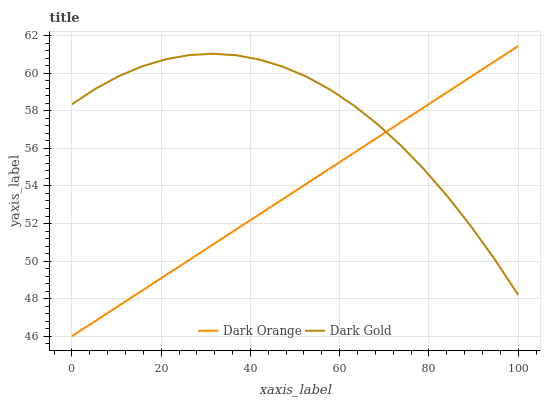Does Dark Orange have the minimum area under the curve?
Answer yes or no. Yes. Does Dark Gold have the maximum area under the curve?
Answer yes or no. Yes. Does Dark Gold have the minimum area under the curve?
Answer yes or no. No. Is Dark Orange the smoothest?
Answer yes or no. Yes. Is Dark Gold the roughest?
Answer yes or no. Yes. Is Dark Gold the smoothest?
Answer yes or no. No. Does Dark Orange have the lowest value?
Answer yes or no. Yes. Does Dark Gold have the lowest value?
Answer yes or no. No. Does Dark Orange have the highest value?
Answer yes or no. Yes. Does Dark Gold have the highest value?
Answer yes or no. No. Does Dark Gold intersect Dark Orange?
Answer yes or no. Yes. Is Dark Gold less than Dark Orange?
Answer yes or no. No. Is Dark Gold greater than Dark Orange?
Answer yes or no. No. 